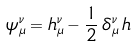Convert formula to latex. <formula><loc_0><loc_0><loc_500><loc_500>\psi _ { \mu } ^ { \nu } = h _ { \mu } ^ { \nu } - \frac { 1 } { 2 } \, \delta _ { \mu } ^ { \nu } \, h</formula> 